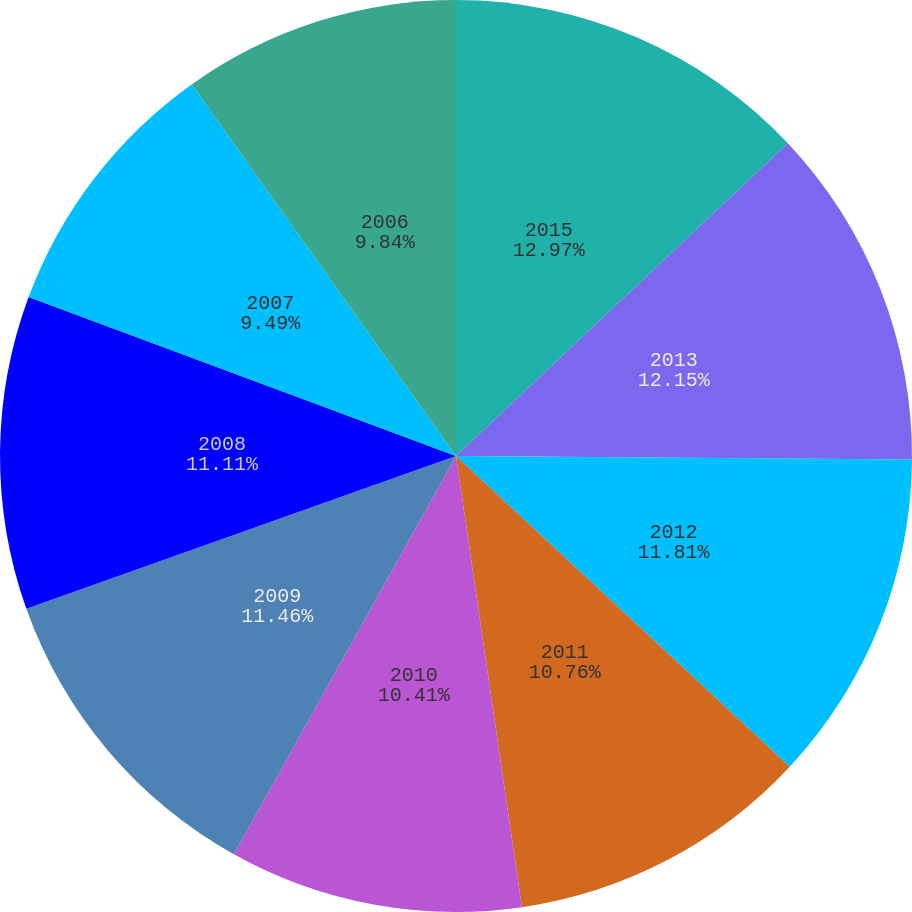Convert chart to OTSL. <chart><loc_0><loc_0><loc_500><loc_500><pie_chart><fcel>2015<fcel>2013<fcel>2012<fcel>2011<fcel>2010<fcel>2009<fcel>2008<fcel>2007<fcel>2006<nl><fcel>12.97%<fcel>12.15%<fcel>11.81%<fcel>10.76%<fcel>10.41%<fcel>11.46%<fcel>11.11%<fcel>9.49%<fcel>9.84%<nl></chart> 